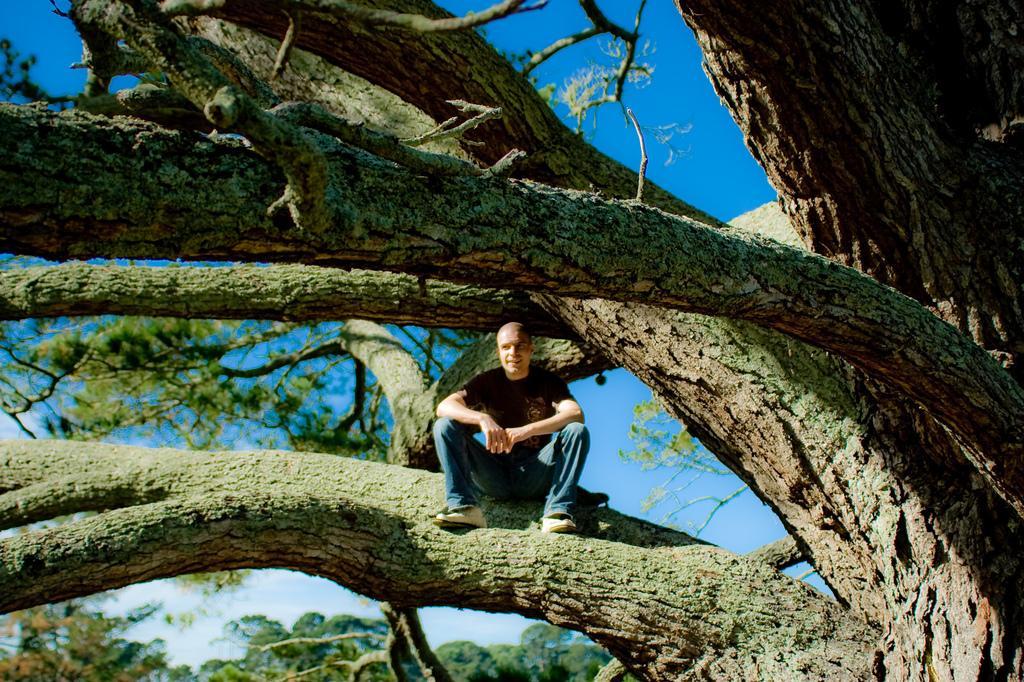Describe this image in one or two sentences. In the middle of the image a man is sitting on a tree. Behind him there is sky. Bottom left side of the image there are some trees. 